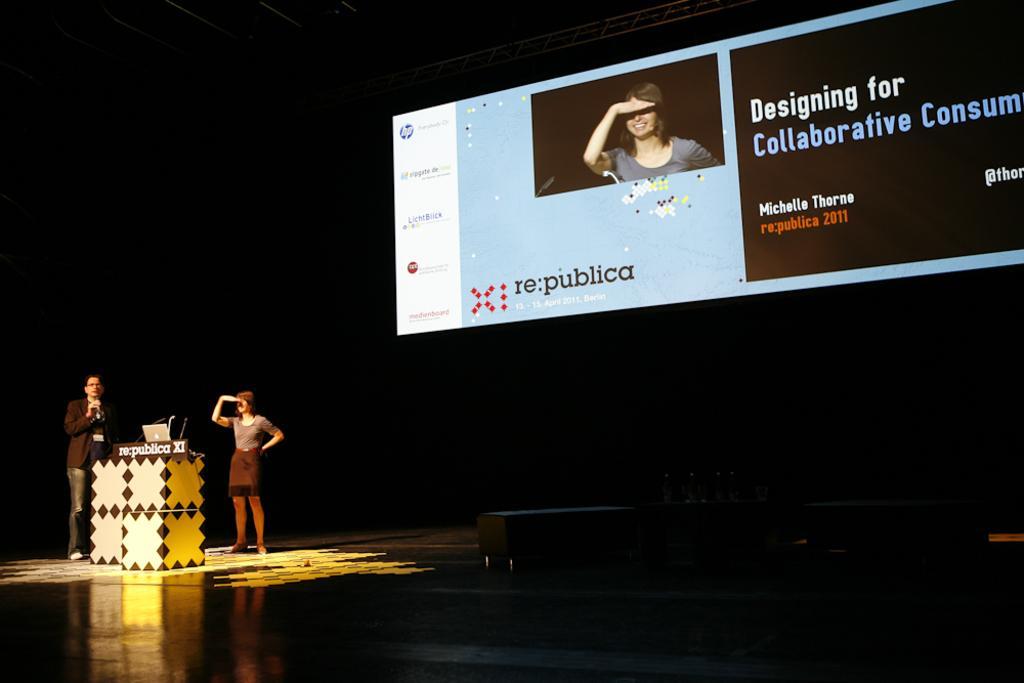In one or two sentences, can you explain what this image depicts? On the left side, there is a person holding a mic and standing near a stand on which, there is a laptop, mic and hoarding. Beside this stand, there is a woman in a skirt standing on the stage. On the right side, there is a screen. And the background is dark in color. 